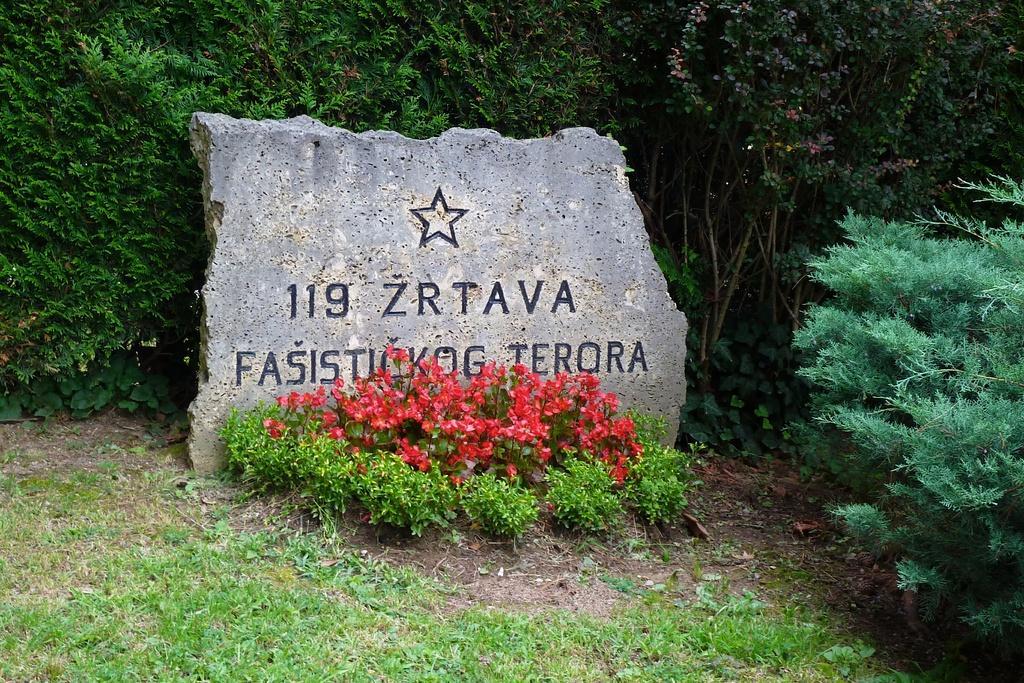Please provide a concise description of this image. In this image, I can see numbers and letters carved on a stone. In front of the stone, there is the grass, plants and flowers. In the background, there are trees. 